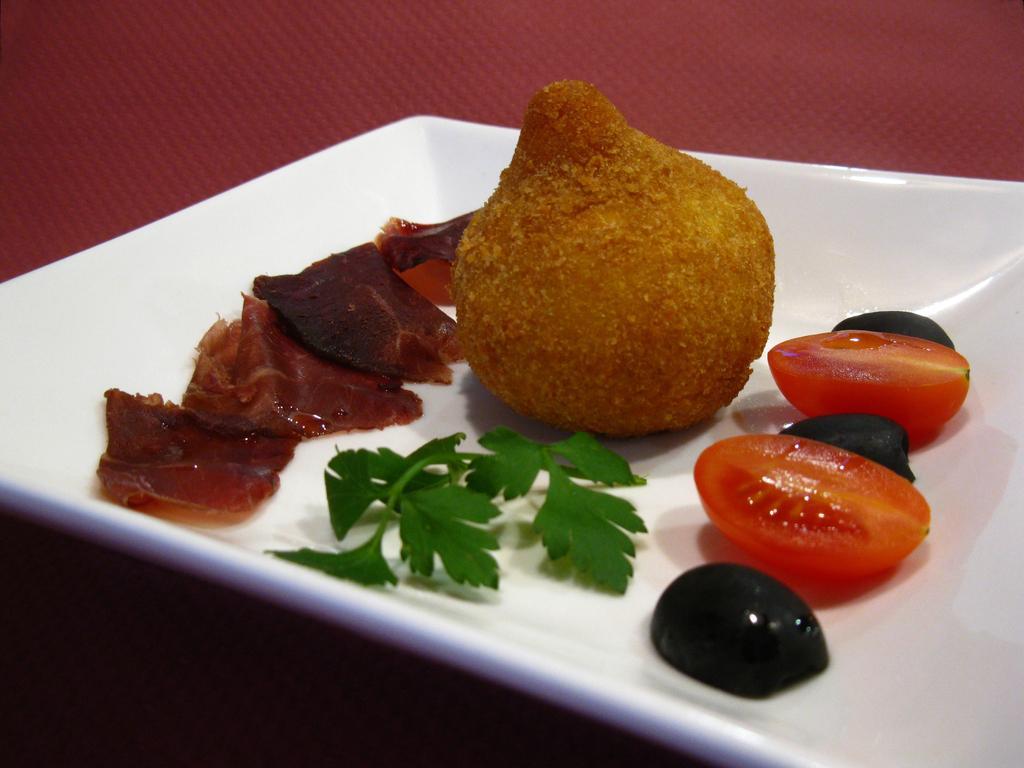Could you give a brief overview of what you see in this image? In this picture I can see a white color plate in front and I can see few coriander leaves, 2 tomato pieces and other food items. I see that this plate is on the red color thing. 